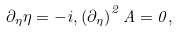<formula> <loc_0><loc_0><loc_500><loc_500>\partial _ { \eta } \eta = - i , \left ( { \partial _ { \eta } } \right ) ^ { 2 } A = 0 ,</formula> 